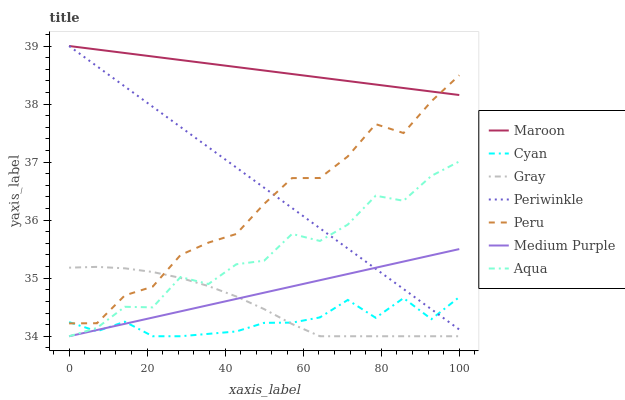Does Cyan have the minimum area under the curve?
Answer yes or no. Yes. Does Maroon have the maximum area under the curve?
Answer yes or no. Yes. Does Aqua have the minimum area under the curve?
Answer yes or no. No. Does Aqua have the maximum area under the curve?
Answer yes or no. No. Is Periwinkle the smoothest?
Answer yes or no. Yes. Is Aqua the roughest?
Answer yes or no. Yes. Is Maroon the smoothest?
Answer yes or no. No. Is Maroon the roughest?
Answer yes or no. No. Does Gray have the lowest value?
Answer yes or no. Yes. Does Maroon have the lowest value?
Answer yes or no. No. Does Periwinkle have the highest value?
Answer yes or no. Yes. Does Aqua have the highest value?
Answer yes or no. No. Is Aqua less than Peru?
Answer yes or no. Yes. Is Peru greater than Aqua?
Answer yes or no. Yes. Does Periwinkle intersect Maroon?
Answer yes or no. Yes. Is Periwinkle less than Maroon?
Answer yes or no. No. Is Periwinkle greater than Maroon?
Answer yes or no. No. Does Aqua intersect Peru?
Answer yes or no. No. 